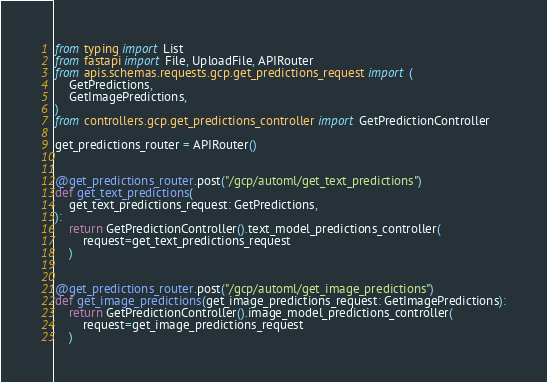<code> <loc_0><loc_0><loc_500><loc_500><_Python_>from typing import List
from fastapi import File, UploadFile, APIRouter
from apis.schemas.requests.gcp.get_predictions_request import (
    GetPredictions,
    GetImagePredictions,
)
from controllers.gcp.get_predictions_controller import GetPredictionController

get_predictions_router = APIRouter()


@get_predictions_router.post("/gcp/automl/get_text_predictions")
def get_text_predictions(
    get_text_predictions_request: GetPredictions,
):
    return GetPredictionController().text_model_predictions_controller(
        request=get_text_predictions_request
    )


@get_predictions_router.post("/gcp/automl/get_image_predictions")
def get_image_predictions(get_image_predictions_request: GetImagePredictions):
    return GetPredictionController().image_model_predictions_controller(
        request=get_image_predictions_request
    )
</code> 